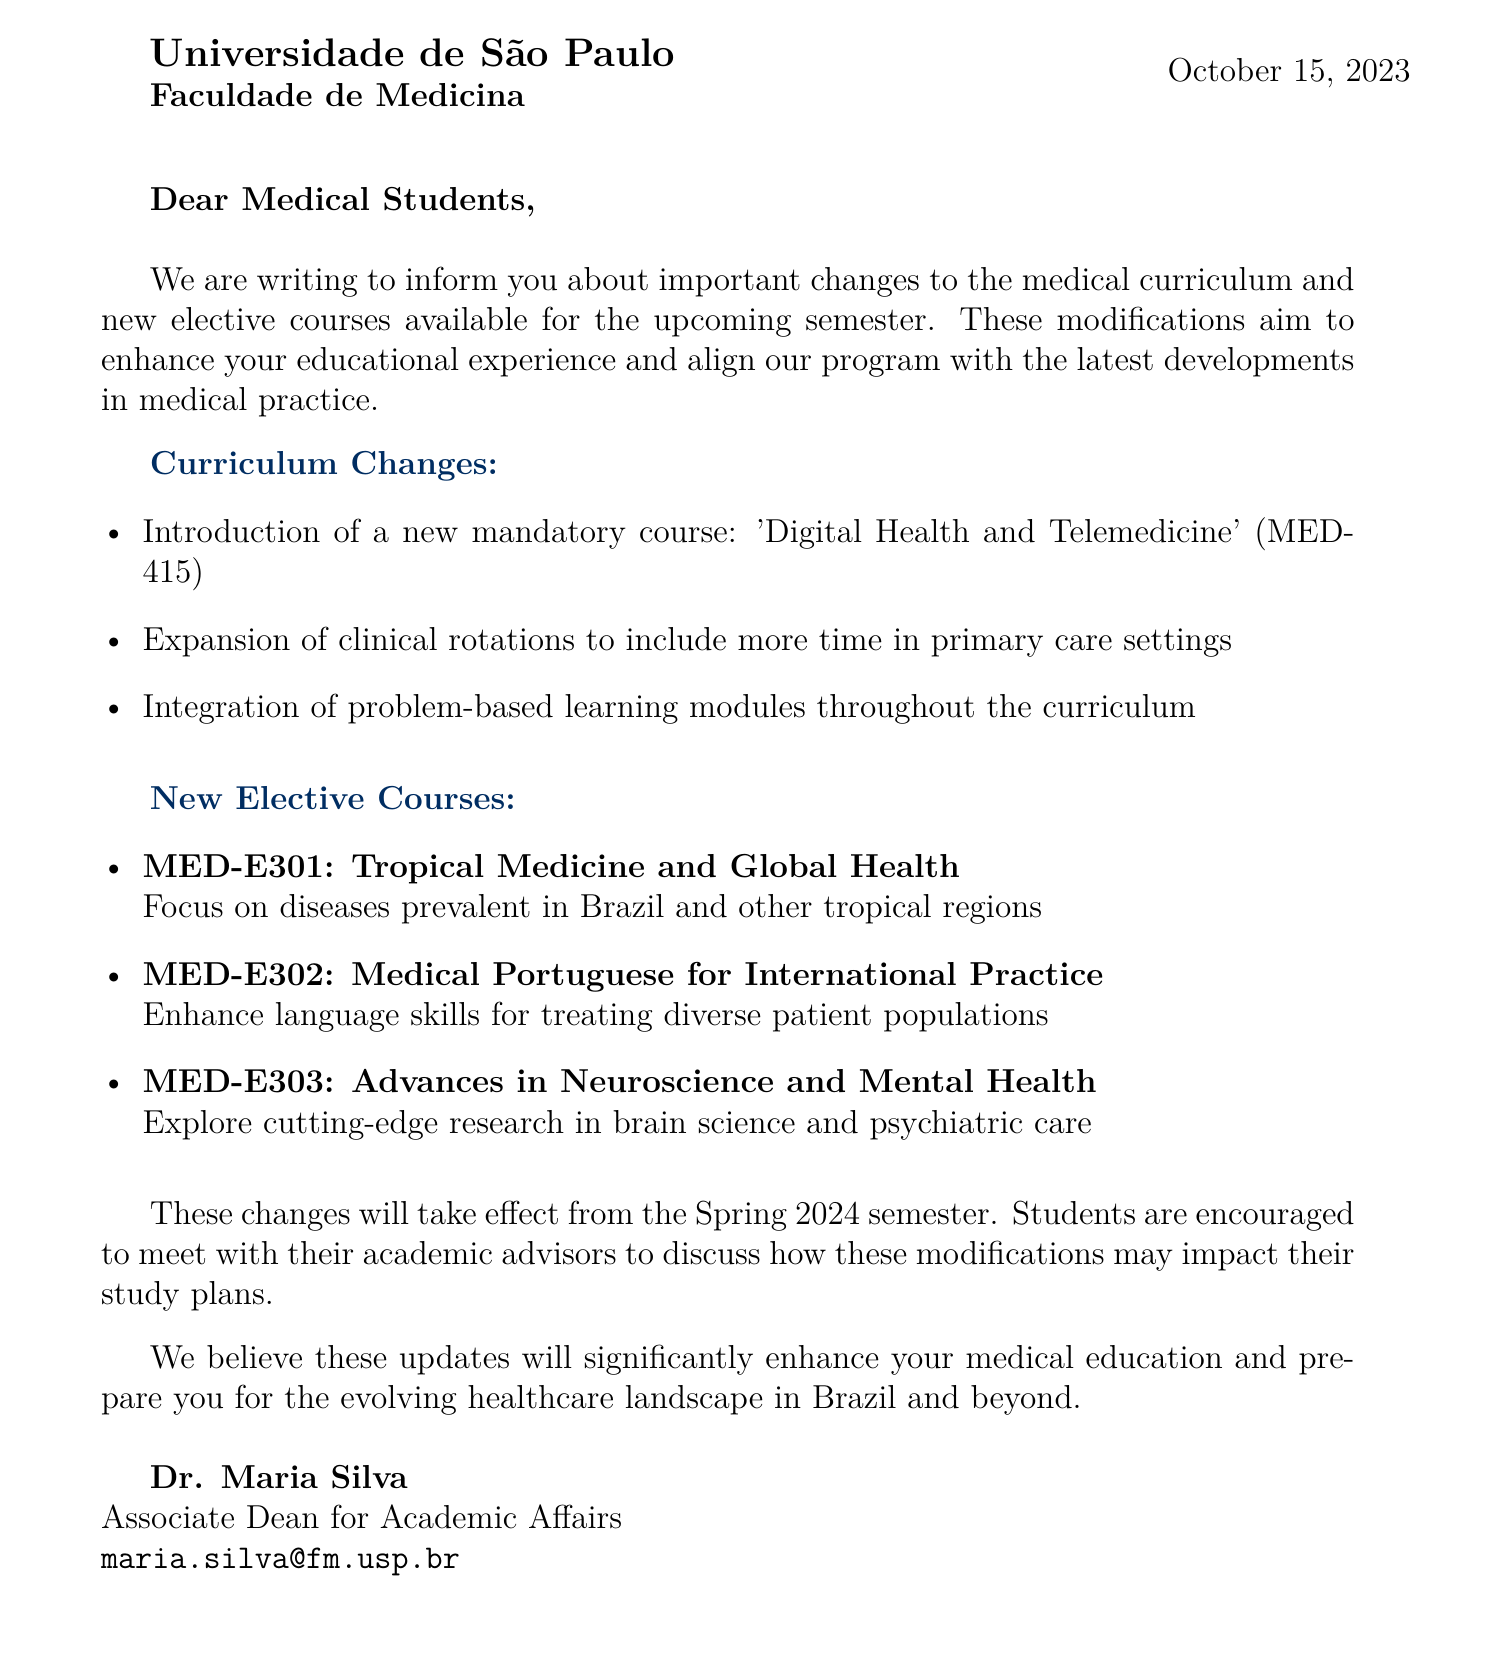What is the name of the university? The letter states that it is from "Universidade de São Paulo."
Answer: Universidade de São Paulo Who is the Associate Dean for Academic Affairs? The contact information lists Dr. Maria Silva as the Associate Dean for Academic Affairs.
Answer: Dr. Maria Silva What is the date of the letter? The letter is dated "October 15, 2023."
Answer: October 15, 2023 How many new elective courses are introduced? There are three new elective courses mentioned in the document.
Answer: Three What is the course code for "Tropical Medicine and Global Health"? The letter specifies that the course code is "MED-E301" for this elective course.
Answer: MED-E301 When will the changes take effect? The letter indicates that these changes will start from the "Spring 2024 semester."
Answer: Spring 2024 What is one of the curriculum changes mentioned? The document lists several changes, such as the introduction of a new mandatory course: 'Digital Health and Telemedicine'.
Answer: 'Digital Health and Telemedicine' What should students do to discuss the changes? The letter encourages students to meet with their academic advisors to discuss how these modifications may impact their study plans.
Answer: Meet with their academic advisors What is the primary goal of the changes to the curriculum? The document states that these modifications aim to enhance the educational experience of students.
Answer: Enhance the educational experience 